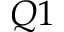Convert formula to latex. <formula><loc_0><loc_0><loc_500><loc_500>Q 1</formula> 